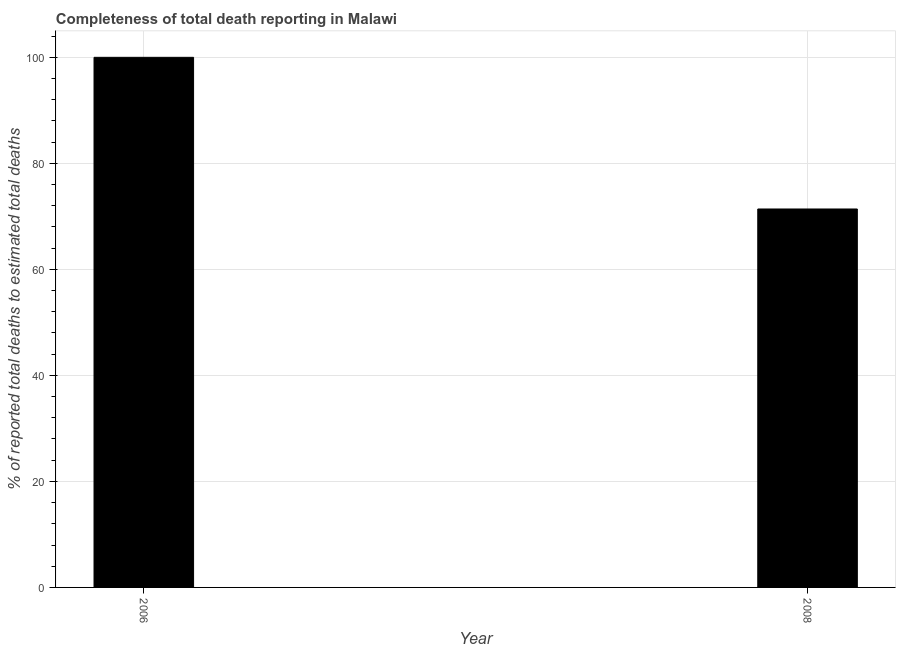Does the graph contain any zero values?
Offer a terse response. No. Does the graph contain grids?
Your answer should be very brief. Yes. What is the title of the graph?
Your answer should be very brief. Completeness of total death reporting in Malawi. What is the label or title of the Y-axis?
Your answer should be compact. % of reported total deaths to estimated total deaths. What is the completeness of total death reports in 2006?
Keep it short and to the point. 100. Across all years, what is the maximum completeness of total death reports?
Ensure brevity in your answer.  100. Across all years, what is the minimum completeness of total death reports?
Your answer should be very brief. 71.39. In which year was the completeness of total death reports maximum?
Make the answer very short. 2006. What is the sum of the completeness of total death reports?
Your answer should be compact. 171.39. What is the difference between the completeness of total death reports in 2006 and 2008?
Keep it short and to the point. 28.61. What is the average completeness of total death reports per year?
Provide a short and direct response. 85.69. What is the median completeness of total death reports?
Provide a succinct answer. 85.7. In how many years, is the completeness of total death reports greater than 16 %?
Provide a succinct answer. 2. What is the ratio of the completeness of total death reports in 2006 to that in 2008?
Your answer should be very brief. 1.4. Are all the bars in the graph horizontal?
Keep it short and to the point. No. How many years are there in the graph?
Your answer should be compact. 2. What is the % of reported total deaths to estimated total deaths of 2006?
Keep it short and to the point. 100. What is the % of reported total deaths to estimated total deaths of 2008?
Give a very brief answer. 71.39. What is the difference between the % of reported total deaths to estimated total deaths in 2006 and 2008?
Provide a succinct answer. 28.61. What is the ratio of the % of reported total deaths to estimated total deaths in 2006 to that in 2008?
Make the answer very short. 1.4. 